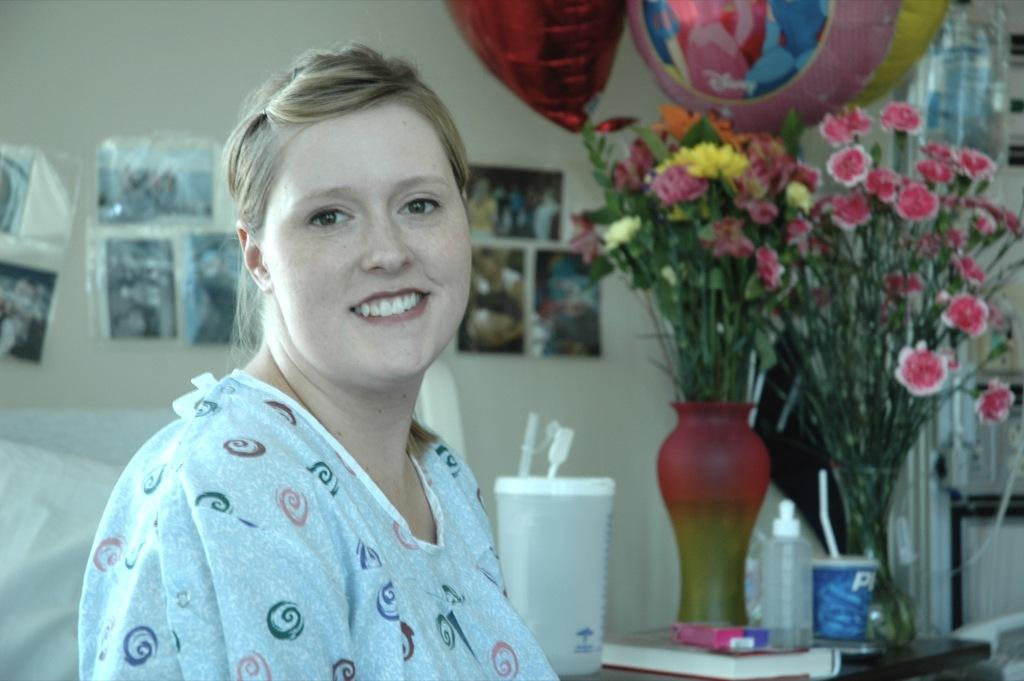Who is present in the image? There is a woman in the image. What is the woman's expression? The woman is smiling. What can be seen in the background of the image? There is a wall in the background of the image. What is on the wall? There are pictures on the wall. What other objects are visible in the image? There is a flower vase and balloons in the image. What type of cord is being used to punish the woman in the image? There is no cord or punishment present in the image; it features a smiling woman with a wall, pictures, a flower vase, and balloons in the background. 